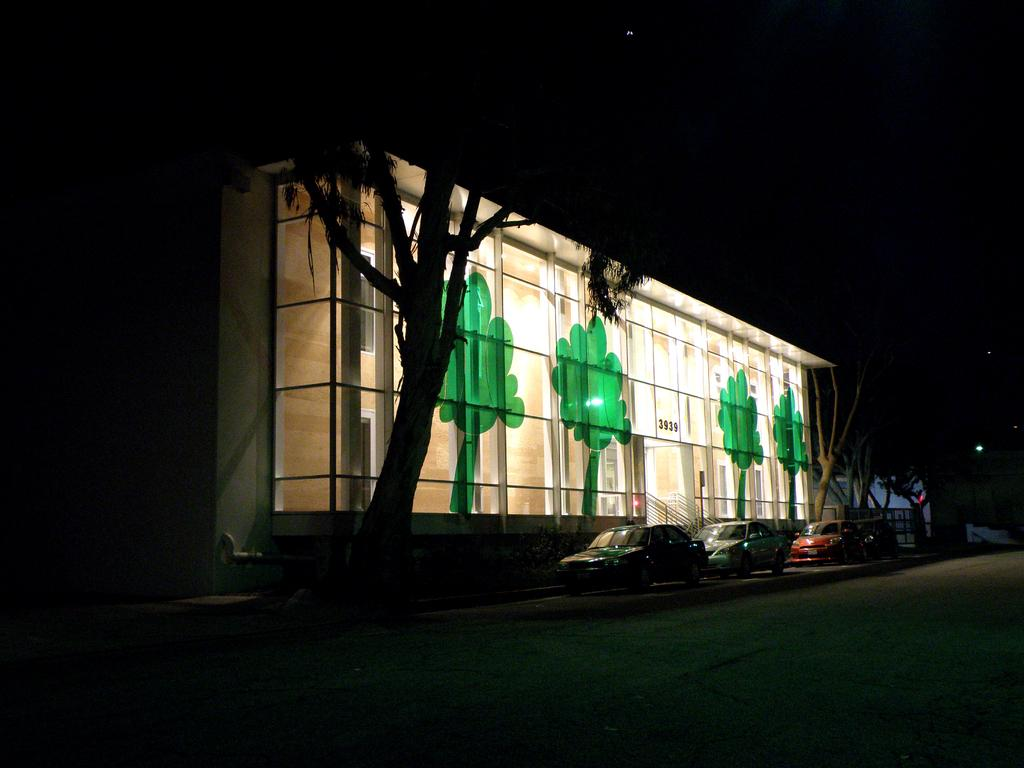What type of structure is visible in the image? There is a building in the image. What can be seen in front of the building? There are trees and vehicles parked in front of the building. What is the color of the background in the image? The background of the image is dark. How does the table increase the muscle strength of the building in the image? There is no table present in the image, and the building's muscle strength is not relevant to the image. 